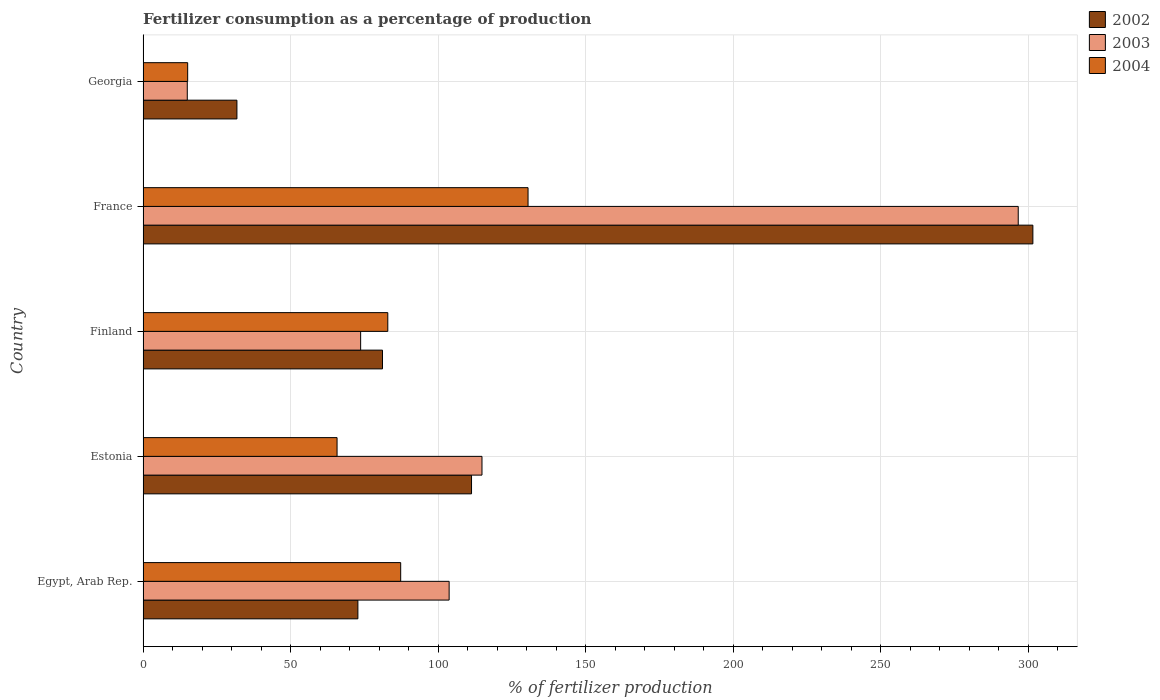Are the number of bars per tick equal to the number of legend labels?
Your response must be concise. Yes. Are the number of bars on each tick of the Y-axis equal?
Keep it short and to the point. Yes. How many bars are there on the 5th tick from the top?
Offer a terse response. 3. What is the label of the 4th group of bars from the top?
Ensure brevity in your answer.  Estonia. What is the percentage of fertilizers consumed in 2003 in Georgia?
Make the answer very short. 14.99. Across all countries, what is the maximum percentage of fertilizers consumed in 2004?
Your response must be concise. 130.46. Across all countries, what is the minimum percentage of fertilizers consumed in 2004?
Provide a succinct answer. 15.12. In which country was the percentage of fertilizers consumed in 2003 maximum?
Make the answer very short. France. In which country was the percentage of fertilizers consumed in 2004 minimum?
Offer a terse response. Georgia. What is the total percentage of fertilizers consumed in 2003 in the graph?
Ensure brevity in your answer.  603.85. What is the difference between the percentage of fertilizers consumed in 2003 in Finland and that in France?
Your response must be concise. -222.83. What is the difference between the percentage of fertilizers consumed in 2002 in Finland and the percentage of fertilizers consumed in 2004 in France?
Offer a terse response. -49.32. What is the average percentage of fertilizers consumed in 2003 per country?
Provide a short and direct response. 120.77. What is the difference between the percentage of fertilizers consumed in 2004 and percentage of fertilizers consumed in 2002 in Egypt, Arab Rep.?
Ensure brevity in your answer.  14.5. What is the ratio of the percentage of fertilizers consumed in 2002 in Egypt, Arab Rep. to that in Georgia?
Give a very brief answer. 2.29. Is the percentage of fertilizers consumed in 2004 in Finland less than that in France?
Make the answer very short. Yes. Is the difference between the percentage of fertilizers consumed in 2004 in Egypt, Arab Rep. and France greater than the difference between the percentage of fertilizers consumed in 2002 in Egypt, Arab Rep. and France?
Give a very brief answer. Yes. What is the difference between the highest and the second highest percentage of fertilizers consumed in 2004?
Give a very brief answer. 43.16. What is the difference between the highest and the lowest percentage of fertilizers consumed in 2002?
Your answer should be very brief. 269.72. In how many countries, is the percentage of fertilizers consumed in 2003 greater than the average percentage of fertilizers consumed in 2003 taken over all countries?
Your answer should be very brief. 1. Is the sum of the percentage of fertilizers consumed in 2003 in Egypt, Arab Rep. and Finland greater than the maximum percentage of fertilizers consumed in 2004 across all countries?
Your answer should be compact. Yes. What does the 1st bar from the bottom in Estonia represents?
Offer a very short reply. 2002. Is it the case that in every country, the sum of the percentage of fertilizers consumed in 2004 and percentage of fertilizers consumed in 2002 is greater than the percentage of fertilizers consumed in 2003?
Your answer should be compact. Yes. How many bars are there?
Ensure brevity in your answer.  15. Are all the bars in the graph horizontal?
Ensure brevity in your answer.  Yes. How many countries are there in the graph?
Provide a short and direct response. 5. Are the values on the major ticks of X-axis written in scientific E-notation?
Your answer should be compact. No. Where does the legend appear in the graph?
Ensure brevity in your answer.  Top right. How many legend labels are there?
Your response must be concise. 3. What is the title of the graph?
Your answer should be very brief. Fertilizer consumption as a percentage of production. Does "1962" appear as one of the legend labels in the graph?
Keep it short and to the point. No. What is the label or title of the X-axis?
Your response must be concise. % of fertilizer production. What is the label or title of the Y-axis?
Your response must be concise. Country. What is the % of fertilizer production in 2002 in Egypt, Arab Rep.?
Your answer should be compact. 72.8. What is the % of fertilizer production of 2003 in Egypt, Arab Rep.?
Make the answer very short. 103.72. What is the % of fertilizer production of 2004 in Egypt, Arab Rep.?
Your answer should be compact. 87.3. What is the % of fertilizer production of 2002 in Estonia?
Your response must be concise. 111.3. What is the % of fertilizer production of 2003 in Estonia?
Offer a terse response. 114.85. What is the % of fertilizer production of 2004 in Estonia?
Your response must be concise. 65.74. What is the % of fertilizer production in 2002 in Finland?
Offer a very short reply. 81.14. What is the % of fertilizer production of 2003 in Finland?
Provide a succinct answer. 73.73. What is the % of fertilizer production in 2004 in Finland?
Keep it short and to the point. 82.93. What is the % of fertilizer production of 2002 in France?
Your answer should be compact. 301.53. What is the % of fertilizer production of 2003 in France?
Offer a very short reply. 296.56. What is the % of fertilizer production of 2004 in France?
Your response must be concise. 130.46. What is the % of fertilizer production in 2002 in Georgia?
Give a very brief answer. 31.81. What is the % of fertilizer production of 2003 in Georgia?
Your response must be concise. 14.99. What is the % of fertilizer production in 2004 in Georgia?
Ensure brevity in your answer.  15.12. Across all countries, what is the maximum % of fertilizer production in 2002?
Ensure brevity in your answer.  301.53. Across all countries, what is the maximum % of fertilizer production of 2003?
Offer a very short reply. 296.56. Across all countries, what is the maximum % of fertilizer production in 2004?
Offer a very short reply. 130.46. Across all countries, what is the minimum % of fertilizer production in 2002?
Your response must be concise. 31.81. Across all countries, what is the minimum % of fertilizer production in 2003?
Your answer should be very brief. 14.99. Across all countries, what is the minimum % of fertilizer production of 2004?
Offer a very short reply. 15.12. What is the total % of fertilizer production of 2002 in the graph?
Your answer should be very brief. 598.57. What is the total % of fertilizer production in 2003 in the graph?
Your response must be concise. 603.85. What is the total % of fertilizer production of 2004 in the graph?
Your answer should be very brief. 381.55. What is the difference between the % of fertilizer production of 2002 in Egypt, Arab Rep. and that in Estonia?
Keep it short and to the point. -38.51. What is the difference between the % of fertilizer production of 2003 in Egypt, Arab Rep. and that in Estonia?
Provide a succinct answer. -11.13. What is the difference between the % of fertilizer production in 2004 in Egypt, Arab Rep. and that in Estonia?
Your answer should be compact. 21.56. What is the difference between the % of fertilizer production in 2002 in Egypt, Arab Rep. and that in Finland?
Ensure brevity in your answer.  -8.34. What is the difference between the % of fertilizer production in 2003 in Egypt, Arab Rep. and that in Finland?
Provide a succinct answer. 29.99. What is the difference between the % of fertilizer production of 2004 in Egypt, Arab Rep. and that in Finland?
Your response must be concise. 4.37. What is the difference between the % of fertilizer production in 2002 in Egypt, Arab Rep. and that in France?
Your answer should be very brief. -228.73. What is the difference between the % of fertilizer production of 2003 in Egypt, Arab Rep. and that in France?
Your answer should be very brief. -192.85. What is the difference between the % of fertilizer production in 2004 in Egypt, Arab Rep. and that in France?
Give a very brief answer. -43.16. What is the difference between the % of fertilizer production in 2002 in Egypt, Arab Rep. and that in Georgia?
Keep it short and to the point. 40.99. What is the difference between the % of fertilizer production in 2003 in Egypt, Arab Rep. and that in Georgia?
Offer a very short reply. 88.73. What is the difference between the % of fertilizer production in 2004 in Egypt, Arab Rep. and that in Georgia?
Your response must be concise. 72.18. What is the difference between the % of fertilizer production in 2002 in Estonia and that in Finland?
Offer a terse response. 30.17. What is the difference between the % of fertilizer production of 2003 in Estonia and that in Finland?
Provide a short and direct response. 41.12. What is the difference between the % of fertilizer production in 2004 in Estonia and that in Finland?
Give a very brief answer. -17.19. What is the difference between the % of fertilizer production in 2002 in Estonia and that in France?
Provide a succinct answer. -190.22. What is the difference between the % of fertilizer production in 2003 in Estonia and that in France?
Provide a short and direct response. -181.71. What is the difference between the % of fertilizer production of 2004 in Estonia and that in France?
Ensure brevity in your answer.  -64.72. What is the difference between the % of fertilizer production of 2002 in Estonia and that in Georgia?
Provide a short and direct response. 79.5. What is the difference between the % of fertilizer production of 2003 in Estonia and that in Georgia?
Make the answer very short. 99.86. What is the difference between the % of fertilizer production in 2004 in Estonia and that in Georgia?
Your answer should be compact. 50.62. What is the difference between the % of fertilizer production of 2002 in Finland and that in France?
Give a very brief answer. -220.39. What is the difference between the % of fertilizer production in 2003 in Finland and that in France?
Offer a very short reply. -222.83. What is the difference between the % of fertilizer production of 2004 in Finland and that in France?
Your answer should be very brief. -47.53. What is the difference between the % of fertilizer production of 2002 in Finland and that in Georgia?
Ensure brevity in your answer.  49.33. What is the difference between the % of fertilizer production in 2003 in Finland and that in Georgia?
Your response must be concise. 58.75. What is the difference between the % of fertilizer production of 2004 in Finland and that in Georgia?
Offer a very short reply. 67.81. What is the difference between the % of fertilizer production of 2002 in France and that in Georgia?
Keep it short and to the point. 269.72. What is the difference between the % of fertilizer production in 2003 in France and that in Georgia?
Your answer should be very brief. 281.58. What is the difference between the % of fertilizer production in 2004 in France and that in Georgia?
Your response must be concise. 115.34. What is the difference between the % of fertilizer production in 2002 in Egypt, Arab Rep. and the % of fertilizer production in 2003 in Estonia?
Provide a succinct answer. -42.05. What is the difference between the % of fertilizer production of 2002 in Egypt, Arab Rep. and the % of fertilizer production of 2004 in Estonia?
Provide a short and direct response. 7.06. What is the difference between the % of fertilizer production in 2003 in Egypt, Arab Rep. and the % of fertilizer production in 2004 in Estonia?
Provide a short and direct response. 37.98. What is the difference between the % of fertilizer production of 2002 in Egypt, Arab Rep. and the % of fertilizer production of 2003 in Finland?
Offer a terse response. -0.94. What is the difference between the % of fertilizer production in 2002 in Egypt, Arab Rep. and the % of fertilizer production in 2004 in Finland?
Make the answer very short. -10.14. What is the difference between the % of fertilizer production of 2003 in Egypt, Arab Rep. and the % of fertilizer production of 2004 in Finland?
Provide a short and direct response. 20.79. What is the difference between the % of fertilizer production in 2002 in Egypt, Arab Rep. and the % of fertilizer production in 2003 in France?
Your answer should be very brief. -223.77. What is the difference between the % of fertilizer production of 2002 in Egypt, Arab Rep. and the % of fertilizer production of 2004 in France?
Provide a succinct answer. -57.66. What is the difference between the % of fertilizer production in 2003 in Egypt, Arab Rep. and the % of fertilizer production in 2004 in France?
Your response must be concise. -26.74. What is the difference between the % of fertilizer production of 2002 in Egypt, Arab Rep. and the % of fertilizer production of 2003 in Georgia?
Provide a succinct answer. 57.81. What is the difference between the % of fertilizer production in 2002 in Egypt, Arab Rep. and the % of fertilizer production in 2004 in Georgia?
Offer a terse response. 57.68. What is the difference between the % of fertilizer production in 2003 in Egypt, Arab Rep. and the % of fertilizer production in 2004 in Georgia?
Your answer should be compact. 88.6. What is the difference between the % of fertilizer production in 2002 in Estonia and the % of fertilizer production in 2003 in Finland?
Offer a terse response. 37.57. What is the difference between the % of fertilizer production in 2002 in Estonia and the % of fertilizer production in 2004 in Finland?
Give a very brief answer. 28.37. What is the difference between the % of fertilizer production of 2003 in Estonia and the % of fertilizer production of 2004 in Finland?
Make the answer very short. 31.92. What is the difference between the % of fertilizer production of 2002 in Estonia and the % of fertilizer production of 2003 in France?
Your answer should be compact. -185.26. What is the difference between the % of fertilizer production of 2002 in Estonia and the % of fertilizer production of 2004 in France?
Provide a succinct answer. -19.16. What is the difference between the % of fertilizer production of 2003 in Estonia and the % of fertilizer production of 2004 in France?
Give a very brief answer. -15.61. What is the difference between the % of fertilizer production in 2002 in Estonia and the % of fertilizer production in 2003 in Georgia?
Offer a very short reply. 96.32. What is the difference between the % of fertilizer production in 2002 in Estonia and the % of fertilizer production in 2004 in Georgia?
Offer a very short reply. 96.19. What is the difference between the % of fertilizer production of 2003 in Estonia and the % of fertilizer production of 2004 in Georgia?
Provide a succinct answer. 99.73. What is the difference between the % of fertilizer production of 2002 in Finland and the % of fertilizer production of 2003 in France?
Provide a succinct answer. -215.43. What is the difference between the % of fertilizer production of 2002 in Finland and the % of fertilizer production of 2004 in France?
Your answer should be compact. -49.32. What is the difference between the % of fertilizer production of 2003 in Finland and the % of fertilizer production of 2004 in France?
Provide a succinct answer. -56.73. What is the difference between the % of fertilizer production in 2002 in Finland and the % of fertilizer production in 2003 in Georgia?
Ensure brevity in your answer.  66.15. What is the difference between the % of fertilizer production of 2002 in Finland and the % of fertilizer production of 2004 in Georgia?
Make the answer very short. 66.02. What is the difference between the % of fertilizer production of 2003 in Finland and the % of fertilizer production of 2004 in Georgia?
Provide a short and direct response. 58.61. What is the difference between the % of fertilizer production in 2002 in France and the % of fertilizer production in 2003 in Georgia?
Provide a succinct answer. 286.54. What is the difference between the % of fertilizer production in 2002 in France and the % of fertilizer production in 2004 in Georgia?
Your response must be concise. 286.41. What is the difference between the % of fertilizer production of 2003 in France and the % of fertilizer production of 2004 in Georgia?
Your response must be concise. 281.45. What is the average % of fertilizer production of 2002 per country?
Your answer should be compact. 119.71. What is the average % of fertilizer production of 2003 per country?
Ensure brevity in your answer.  120.77. What is the average % of fertilizer production of 2004 per country?
Give a very brief answer. 76.31. What is the difference between the % of fertilizer production of 2002 and % of fertilizer production of 2003 in Egypt, Arab Rep.?
Offer a very short reply. -30.92. What is the difference between the % of fertilizer production in 2002 and % of fertilizer production in 2004 in Egypt, Arab Rep.?
Your answer should be compact. -14.5. What is the difference between the % of fertilizer production in 2003 and % of fertilizer production in 2004 in Egypt, Arab Rep.?
Offer a very short reply. 16.42. What is the difference between the % of fertilizer production in 2002 and % of fertilizer production in 2003 in Estonia?
Give a very brief answer. -3.55. What is the difference between the % of fertilizer production in 2002 and % of fertilizer production in 2004 in Estonia?
Your answer should be compact. 45.57. What is the difference between the % of fertilizer production of 2003 and % of fertilizer production of 2004 in Estonia?
Your answer should be very brief. 49.11. What is the difference between the % of fertilizer production in 2002 and % of fertilizer production in 2003 in Finland?
Offer a terse response. 7.41. What is the difference between the % of fertilizer production of 2002 and % of fertilizer production of 2004 in Finland?
Offer a very short reply. -1.79. What is the difference between the % of fertilizer production of 2003 and % of fertilizer production of 2004 in Finland?
Offer a very short reply. -9.2. What is the difference between the % of fertilizer production in 2002 and % of fertilizer production in 2003 in France?
Offer a very short reply. 4.96. What is the difference between the % of fertilizer production of 2002 and % of fertilizer production of 2004 in France?
Provide a succinct answer. 171.07. What is the difference between the % of fertilizer production of 2003 and % of fertilizer production of 2004 in France?
Give a very brief answer. 166.1. What is the difference between the % of fertilizer production of 2002 and % of fertilizer production of 2003 in Georgia?
Keep it short and to the point. 16.82. What is the difference between the % of fertilizer production in 2002 and % of fertilizer production in 2004 in Georgia?
Offer a terse response. 16.69. What is the difference between the % of fertilizer production in 2003 and % of fertilizer production in 2004 in Georgia?
Your answer should be very brief. -0.13. What is the ratio of the % of fertilizer production of 2002 in Egypt, Arab Rep. to that in Estonia?
Your answer should be very brief. 0.65. What is the ratio of the % of fertilizer production in 2003 in Egypt, Arab Rep. to that in Estonia?
Offer a terse response. 0.9. What is the ratio of the % of fertilizer production of 2004 in Egypt, Arab Rep. to that in Estonia?
Ensure brevity in your answer.  1.33. What is the ratio of the % of fertilizer production in 2002 in Egypt, Arab Rep. to that in Finland?
Keep it short and to the point. 0.9. What is the ratio of the % of fertilizer production of 2003 in Egypt, Arab Rep. to that in Finland?
Your response must be concise. 1.41. What is the ratio of the % of fertilizer production in 2004 in Egypt, Arab Rep. to that in Finland?
Your response must be concise. 1.05. What is the ratio of the % of fertilizer production of 2002 in Egypt, Arab Rep. to that in France?
Ensure brevity in your answer.  0.24. What is the ratio of the % of fertilizer production of 2003 in Egypt, Arab Rep. to that in France?
Your response must be concise. 0.35. What is the ratio of the % of fertilizer production in 2004 in Egypt, Arab Rep. to that in France?
Keep it short and to the point. 0.67. What is the ratio of the % of fertilizer production of 2002 in Egypt, Arab Rep. to that in Georgia?
Keep it short and to the point. 2.29. What is the ratio of the % of fertilizer production of 2003 in Egypt, Arab Rep. to that in Georgia?
Your response must be concise. 6.92. What is the ratio of the % of fertilizer production in 2004 in Egypt, Arab Rep. to that in Georgia?
Your answer should be compact. 5.77. What is the ratio of the % of fertilizer production of 2002 in Estonia to that in Finland?
Ensure brevity in your answer.  1.37. What is the ratio of the % of fertilizer production of 2003 in Estonia to that in Finland?
Offer a very short reply. 1.56. What is the ratio of the % of fertilizer production in 2004 in Estonia to that in Finland?
Your answer should be very brief. 0.79. What is the ratio of the % of fertilizer production of 2002 in Estonia to that in France?
Keep it short and to the point. 0.37. What is the ratio of the % of fertilizer production of 2003 in Estonia to that in France?
Give a very brief answer. 0.39. What is the ratio of the % of fertilizer production of 2004 in Estonia to that in France?
Ensure brevity in your answer.  0.5. What is the ratio of the % of fertilizer production of 2002 in Estonia to that in Georgia?
Provide a short and direct response. 3.5. What is the ratio of the % of fertilizer production in 2003 in Estonia to that in Georgia?
Your answer should be compact. 7.66. What is the ratio of the % of fertilizer production in 2004 in Estonia to that in Georgia?
Offer a very short reply. 4.35. What is the ratio of the % of fertilizer production in 2002 in Finland to that in France?
Your answer should be very brief. 0.27. What is the ratio of the % of fertilizer production in 2003 in Finland to that in France?
Ensure brevity in your answer.  0.25. What is the ratio of the % of fertilizer production of 2004 in Finland to that in France?
Keep it short and to the point. 0.64. What is the ratio of the % of fertilizer production in 2002 in Finland to that in Georgia?
Make the answer very short. 2.55. What is the ratio of the % of fertilizer production in 2003 in Finland to that in Georgia?
Your answer should be very brief. 4.92. What is the ratio of the % of fertilizer production of 2004 in Finland to that in Georgia?
Make the answer very short. 5.49. What is the ratio of the % of fertilizer production of 2002 in France to that in Georgia?
Your answer should be compact. 9.48. What is the ratio of the % of fertilizer production in 2003 in France to that in Georgia?
Your answer should be very brief. 19.79. What is the ratio of the % of fertilizer production in 2004 in France to that in Georgia?
Keep it short and to the point. 8.63. What is the difference between the highest and the second highest % of fertilizer production in 2002?
Offer a terse response. 190.22. What is the difference between the highest and the second highest % of fertilizer production of 2003?
Your response must be concise. 181.71. What is the difference between the highest and the second highest % of fertilizer production of 2004?
Provide a short and direct response. 43.16. What is the difference between the highest and the lowest % of fertilizer production of 2002?
Your answer should be very brief. 269.72. What is the difference between the highest and the lowest % of fertilizer production of 2003?
Ensure brevity in your answer.  281.58. What is the difference between the highest and the lowest % of fertilizer production in 2004?
Offer a very short reply. 115.34. 